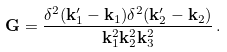Convert formula to latex. <formula><loc_0><loc_0><loc_500><loc_500>\mathbf G = \frac { \delta ^ { 2 } ( \mathbf k ^ { \prime } _ { 1 } - \mathbf k _ { 1 } ) \delta ^ { 2 } ( \mathbf k ^ { \prime } _ { 2 } - \mathbf k _ { 2 } ) } { \mathbf k _ { 1 } ^ { 2 } \mathbf k _ { 2 } ^ { 2 } \mathbf k _ { 3 } ^ { 2 } } \, .</formula> 